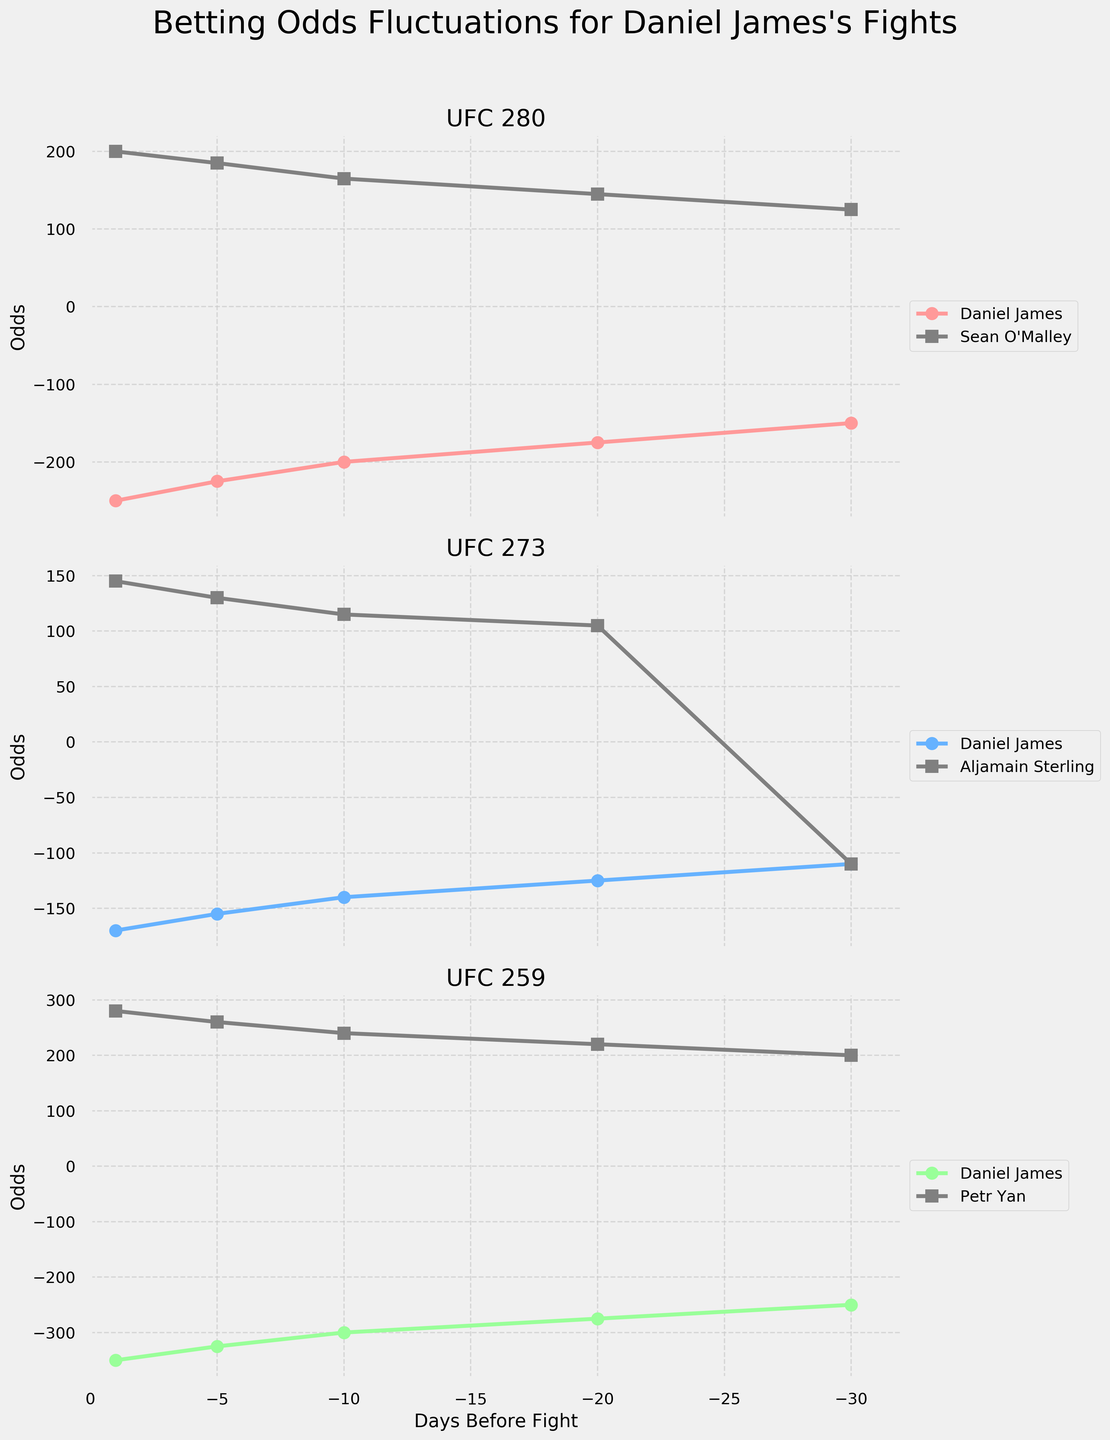How many events are shown in the figure? The figure is composed of subplots, each representing a different event. By counting the titles of the subplots, we can see that there are three distinct event titles.
Answer: 3 What's the title of the figure? The title of the figure is displayed at the top and reads "Betting Odds Fluctuations for Daniel James's Fights."
Answer: Betting Odds Fluctuations for Daniel James's Fights How do the betting odds for Daniel James change as we get closer to the fight day in UFC 280? For UFC 280, observe the line labeled "Daniel James." The odds start at -150 at 30 days before the fight and progressively decrease to -250 by 1 day before the fight. This indicates that the betting odds become more favorable for Daniel James as the fight day approaches.
Answer: Decrease from -150 to -250 Which event shows Daniel James initially being an equal favorite compared to his opponent? Look at the starting point (30 days before the fight) for each event. In UFC 273, Daniel James and Aljamain Sterling are both at -110, indicating they are equally favored.
Answer: UFC 273 For which event did Daniel James have the most unfavorable odds 30 days before the fight? Compare Daniel James's odds 30 days before each event. The most unfavorable odds are indicated by the numerically largest value. For UFC 259, the odds are -250, which is the most unfavorable among the three events.
Answer: UFC 259 Which event had the widest range of odds fluctuation for Daniel James? To identify the event with the widest fluctuation range, calculate the difference between the highest and lowest odds for Daniel James across the timeline for each event. For UFC 259, the difference is the largest: from -250 to -350, a range of 100.
Answer: UFC 259 Compare the trend of betting odds for Daniel James and his opponents in UFC 273. For UFC 273, observe the lines for both Daniel James and Aljamain Sterling. Daniel James's odds are becoming more favorable (decreasing), while Aljamain Sterling's odds become less favorable (increasing).
Answer: Daniel James: decreasing, Opponent: increasing At one day before the fight, was Daniel James ever the underdog in any of these events? Look at the odds for Daniel James one day before each fight. In all events (UFC 280, UFC 273, UFC 259), the value is negative, indicating he was the favorite in each case.
Answer: No In which event did Daniel James have the most favorable odds improvement over the last 10 days? Compare the change in odds over the last 10 days for each event. The greatest improvement is seen in UFC 259, where the odds improved from -300 to -350, a difference of 50.
Answer: UFC 259 